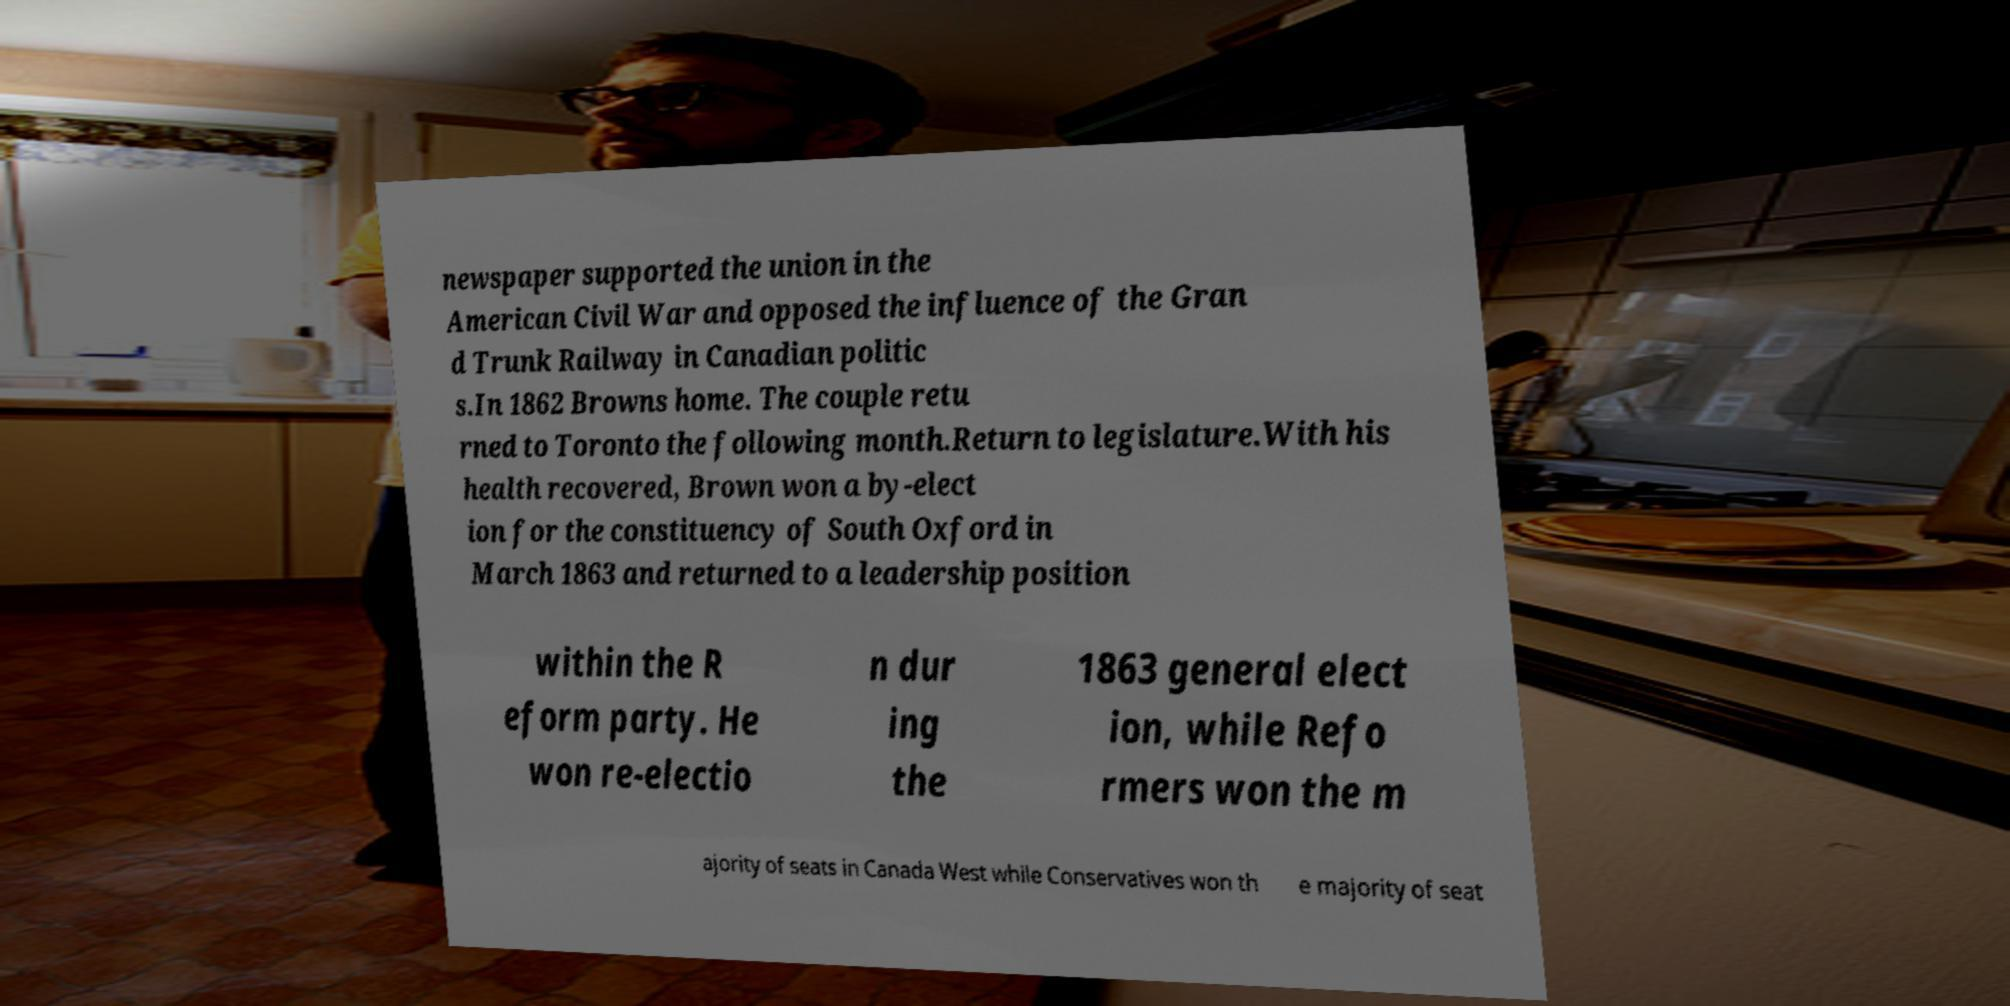For documentation purposes, I need the text within this image transcribed. Could you provide that? newspaper supported the union in the American Civil War and opposed the influence of the Gran d Trunk Railway in Canadian politic s.In 1862 Browns home. The couple retu rned to Toronto the following month.Return to legislature.With his health recovered, Brown won a by-elect ion for the constituency of South Oxford in March 1863 and returned to a leadership position within the R eform party. He won re-electio n dur ing the 1863 general elect ion, while Refo rmers won the m ajority of seats in Canada West while Conservatives won th e majority of seat 